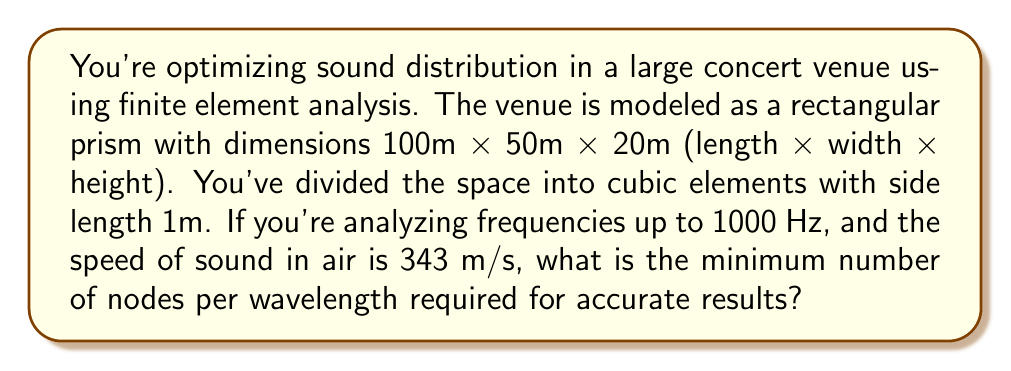Provide a solution to this math problem. To determine the minimum number of nodes per wavelength for accurate finite element analysis, we need to follow these steps:

1. Calculate the wavelength of the highest frequency:
   The wavelength $\lambda$ is given by the equation:
   $$\lambda = \frac{c}{f}$$
   where $c$ is the speed of sound and $f$ is the frequency.
   
   $$\lambda = \frac{343 \text{ m/s}}{1000 \text{ Hz}} = 0.343 \text{ m}$$

2. Determine the element size:
   The cubic elements have a side length of 1m, so the element size is 1m.

3. Calculate the number of elements per wavelength:
   $$\text{Elements per wavelength} = \frac{\lambda}{\text{Element size}} = \frac{0.343 \text{ m}}{1 \text{ m}} = 0.343$$

4. Determine the minimum number of nodes per wavelength:
   For accurate results in finite element analysis, a general rule of thumb is to have at least 6-10 nodes per wavelength. Since we have cubic elements, each element contributes 2 nodes along each dimension.

   Given that we have 0.343 elements per wavelength, and each element contributes 2 nodes, we have:
   $$\text{Nodes per wavelength} = 0.343 \times 2 = 0.686$$

5. Calculate the minimum number of nodes required:
   To meet the minimum requirement of 6 nodes per wavelength, we need to increase our node density by a factor of:
   $$\frac{6}{0.686} = 8.75$$

   Rounding up to the nearest integer gives us 9.

Therefore, we need to increase our node density by a factor of 9, which means dividing our element size by 9. This will result in approximately 6.17 nodes per wavelength, meeting the minimum requirement for accurate analysis.
Answer: 9 